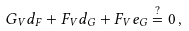Convert formula to latex. <formula><loc_0><loc_0><loc_500><loc_500>G _ { V } d _ { F } + F _ { V } d _ { G } + F _ { V } e _ { G } \stackrel { ? } { = } 0 \, ,</formula> 